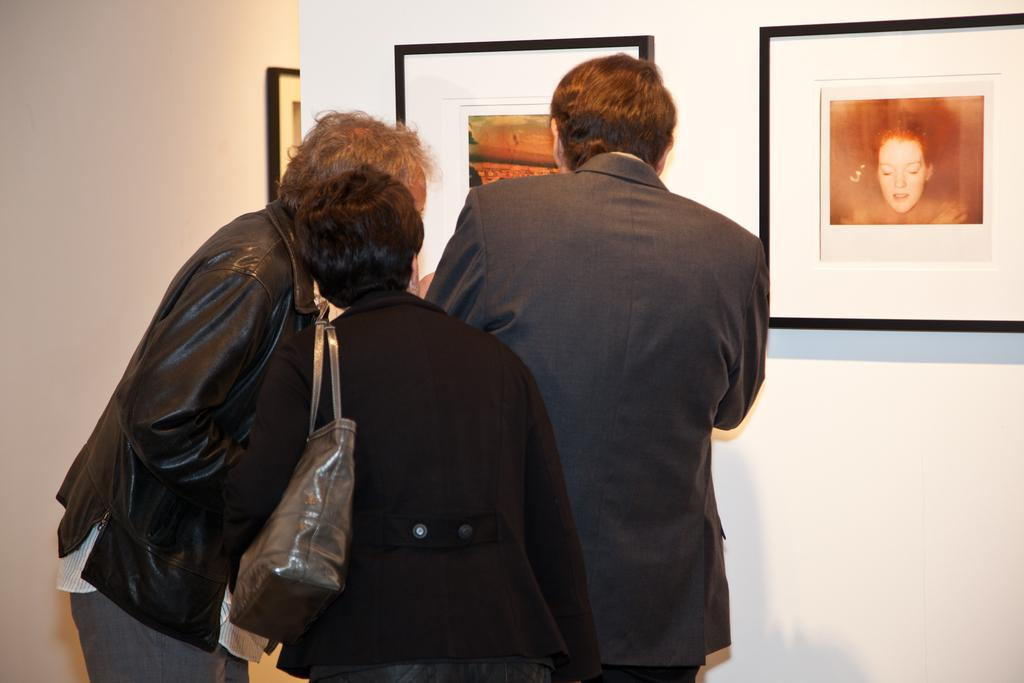What can be seen on the left side of the image? There are people standing on the left side of the image. What is the background of the people in the image? The people are standing in front of portraits on the wall. What type of toothbrush is being used by the people in the image? There is no toothbrush present in the image; the people are standing in front of portraits on the wall. 